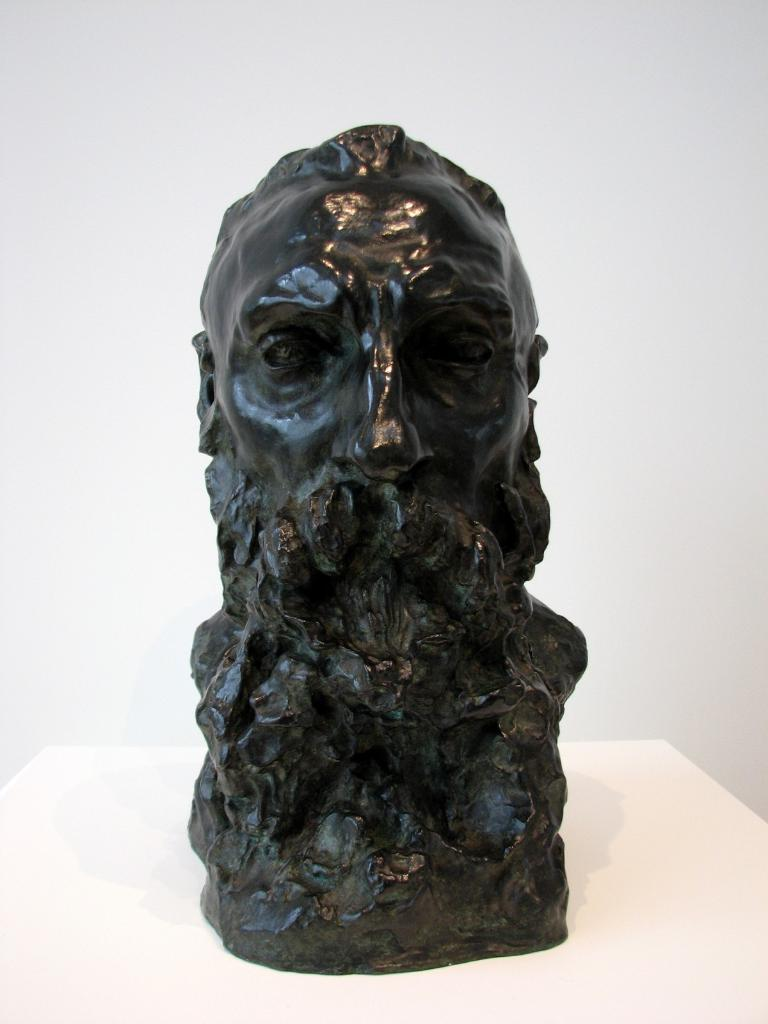What is the main subject in the center of the image? There is a sculpture in the center of the image. Where is the sculpture located? The sculpture is on a table. What can be seen in the background of the image? There is a wall in the background of the image. What type of crate is used to store the sculpture in the image? There is no crate present in the image; the sculpture is on a table. 